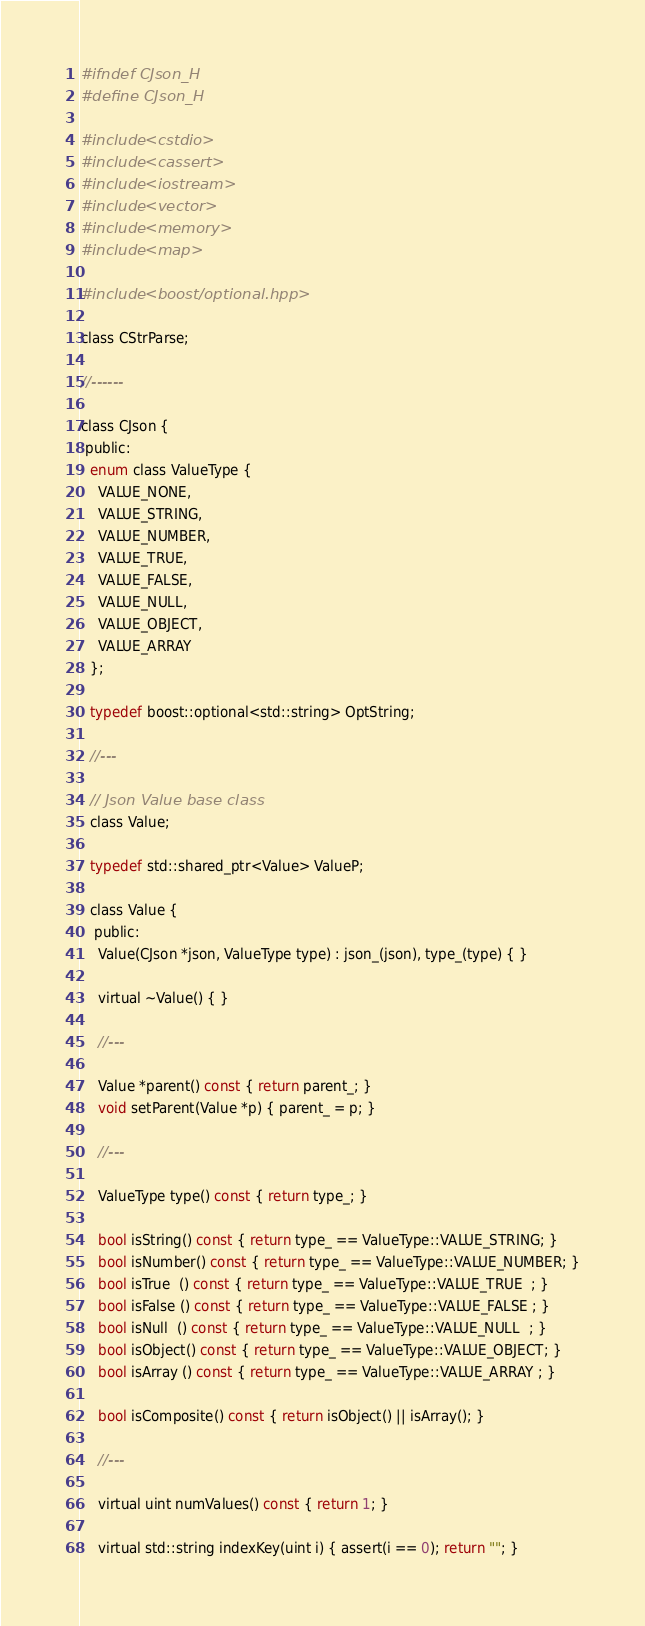Convert code to text. <code><loc_0><loc_0><loc_500><loc_500><_C_>#ifndef CJson_H
#define CJson_H

#include <cstdio>
#include <cassert>
#include <iostream>
#include <vector>
#include <memory>
#include <map>

#include <boost/optional.hpp>

class CStrParse;

//------

class CJson {
 public:
  enum class ValueType {
    VALUE_NONE,
    VALUE_STRING,
    VALUE_NUMBER,
    VALUE_TRUE,
    VALUE_FALSE,
    VALUE_NULL,
    VALUE_OBJECT,
    VALUE_ARRAY
  };

  typedef boost::optional<std::string> OptString;

  //---

  // Json Value base class
  class Value;

  typedef std::shared_ptr<Value> ValueP;

  class Value {
   public:
    Value(CJson *json, ValueType type) : json_(json), type_(type) { }

    virtual ~Value() { }

    //---

    Value *parent() const { return parent_; }
    void setParent(Value *p) { parent_ = p; }

    //---

    ValueType type() const { return type_; }

    bool isString() const { return type_ == ValueType::VALUE_STRING; }
    bool isNumber() const { return type_ == ValueType::VALUE_NUMBER; }
    bool isTrue  () const { return type_ == ValueType::VALUE_TRUE  ; }
    bool isFalse () const { return type_ == ValueType::VALUE_FALSE ; }
    bool isNull  () const { return type_ == ValueType::VALUE_NULL  ; }
    bool isObject() const { return type_ == ValueType::VALUE_OBJECT; }
    bool isArray () const { return type_ == ValueType::VALUE_ARRAY ; }

    bool isComposite() const { return isObject() || isArray(); }

    //---

    virtual uint numValues() const { return 1; }

    virtual std::string indexKey(uint i) { assert(i == 0); return ""; }
</code> 